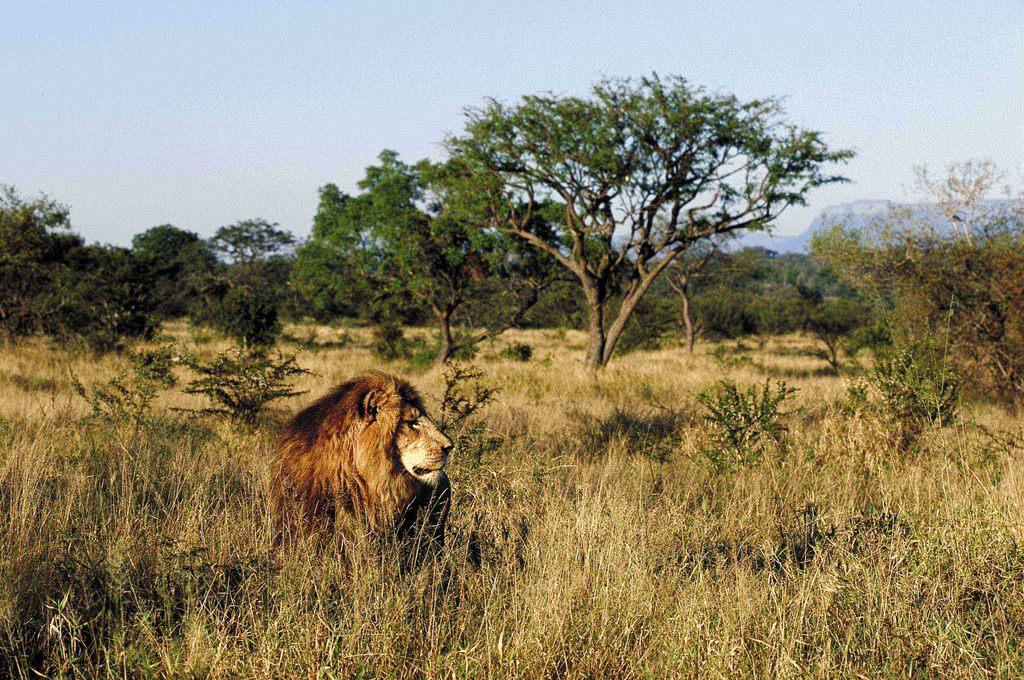What animal is located on the left side of the image? There is a lion on the left side of the image. What type of vegetation can be seen in the image? There are trees in the image. What is the ground cover in the image? There is dry grass in the image. What type of secretary can be seen working in the image? There is no secretary present in the image; it features a lion and vegetation. What type of engine is visible in the image? There is no engine present in the image. 